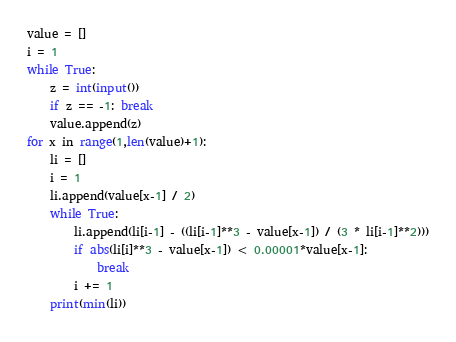<code> <loc_0><loc_0><loc_500><loc_500><_Python_>value = []
i = 1
while True:
	z = int(input())
	if z == -1: break
	value.append(z)
for x in range(1,len(value)+1):
	li = []
	i = 1
	li.append(value[x-1] / 2)
	while True:
		li.append(li[i-1] - ((li[i-1]**3 - value[x-1]) / (3 * li[i-1]**2)))
		if abs(li[i]**3 - value[x-1]) < 0.00001*value[x-1]:
			break
		i += 1
	print(min(li))
</code> 